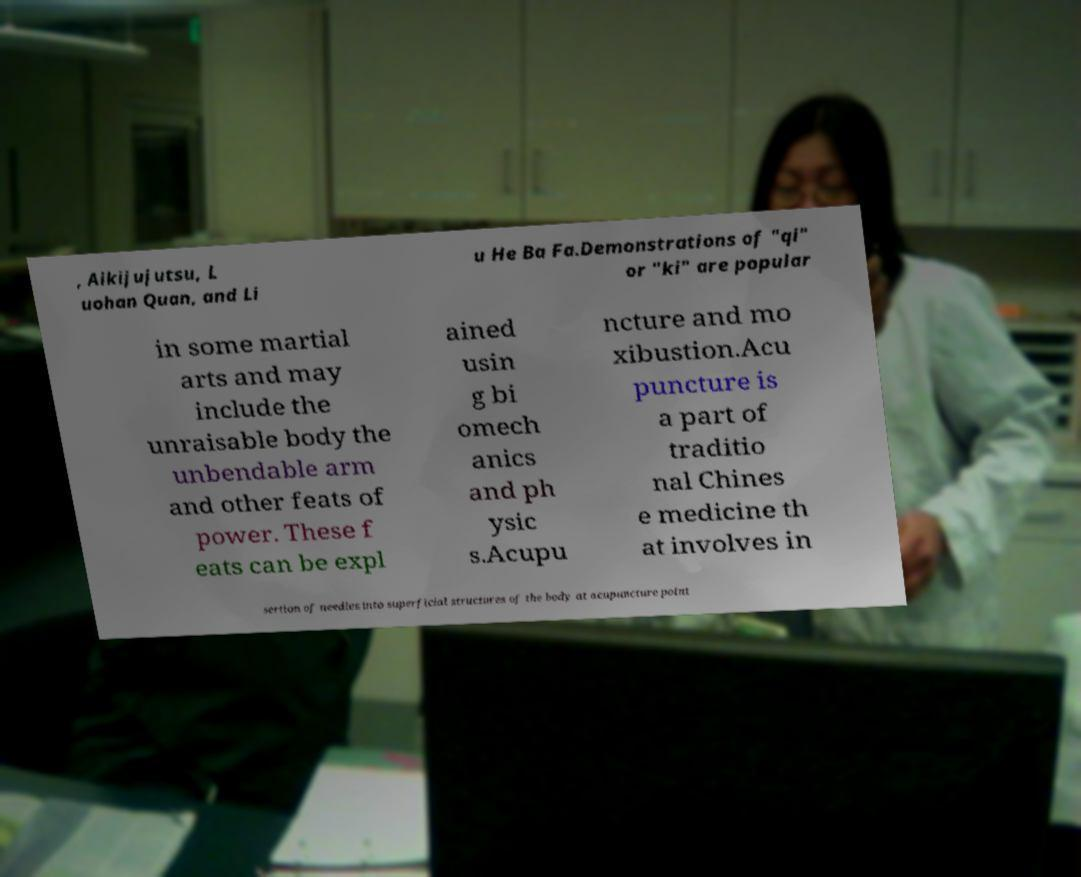Please read and relay the text visible in this image. What does it say? , Aikijujutsu, L uohan Quan, and Li u He Ba Fa.Demonstrations of "qi" or "ki" are popular in some martial arts and may include the unraisable body the unbendable arm and other feats of power. These f eats can be expl ained usin g bi omech anics and ph ysic s.Acupu ncture and mo xibustion.Acu puncture is a part of traditio nal Chines e medicine th at involves in sertion of needles into superficial structures of the body at acupuncture point 